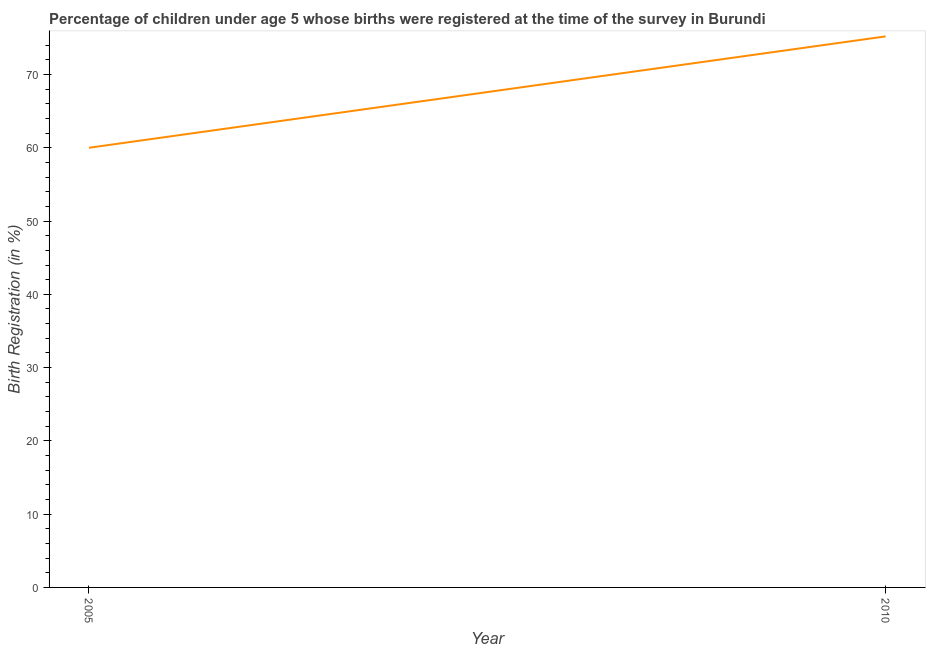Across all years, what is the maximum birth registration?
Your response must be concise. 75.2. Across all years, what is the minimum birth registration?
Make the answer very short. 60. In which year was the birth registration maximum?
Your answer should be compact. 2010. In which year was the birth registration minimum?
Offer a very short reply. 2005. What is the sum of the birth registration?
Ensure brevity in your answer.  135.2. What is the difference between the birth registration in 2005 and 2010?
Your response must be concise. -15.2. What is the average birth registration per year?
Offer a terse response. 67.6. What is the median birth registration?
Your answer should be compact. 67.6. In how many years, is the birth registration greater than 2 %?
Make the answer very short. 2. Do a majority of the years between 2010 and 2005 (inclusive) have birth registration greater than 8 %?
Your response must be concise. No. What is the ratio of the birth registration in 2005 to that in 2010?
Make the answer very short. 0.8. Does the birth registration monotonically increase over the years?
Ensure brevity in your answer.  Yes. Does the graph contain grids?
Give a very brief answer. No. What is the title of the graph?
Make the answer very short. Percentage of children under age 5 whose births were registered at the time of the survey in Burundi. What is the label or title of the X-axis?
Make the answer very short. Year. What is the label or title of the Y-axis?
Offer a terse response. Birth Registration (in %). What is the Birth Registration (in %) in 2010?
Ensure brevity in your answer.  75.2. What is the difference between the Birth Registration (in %) in 2005 and 2010?
Your answer should be compact. -15.2. What is the ratio of the Birth Registration (in %) in 2005 to that in 2010?
Your answer should be very brief. 0.8. 